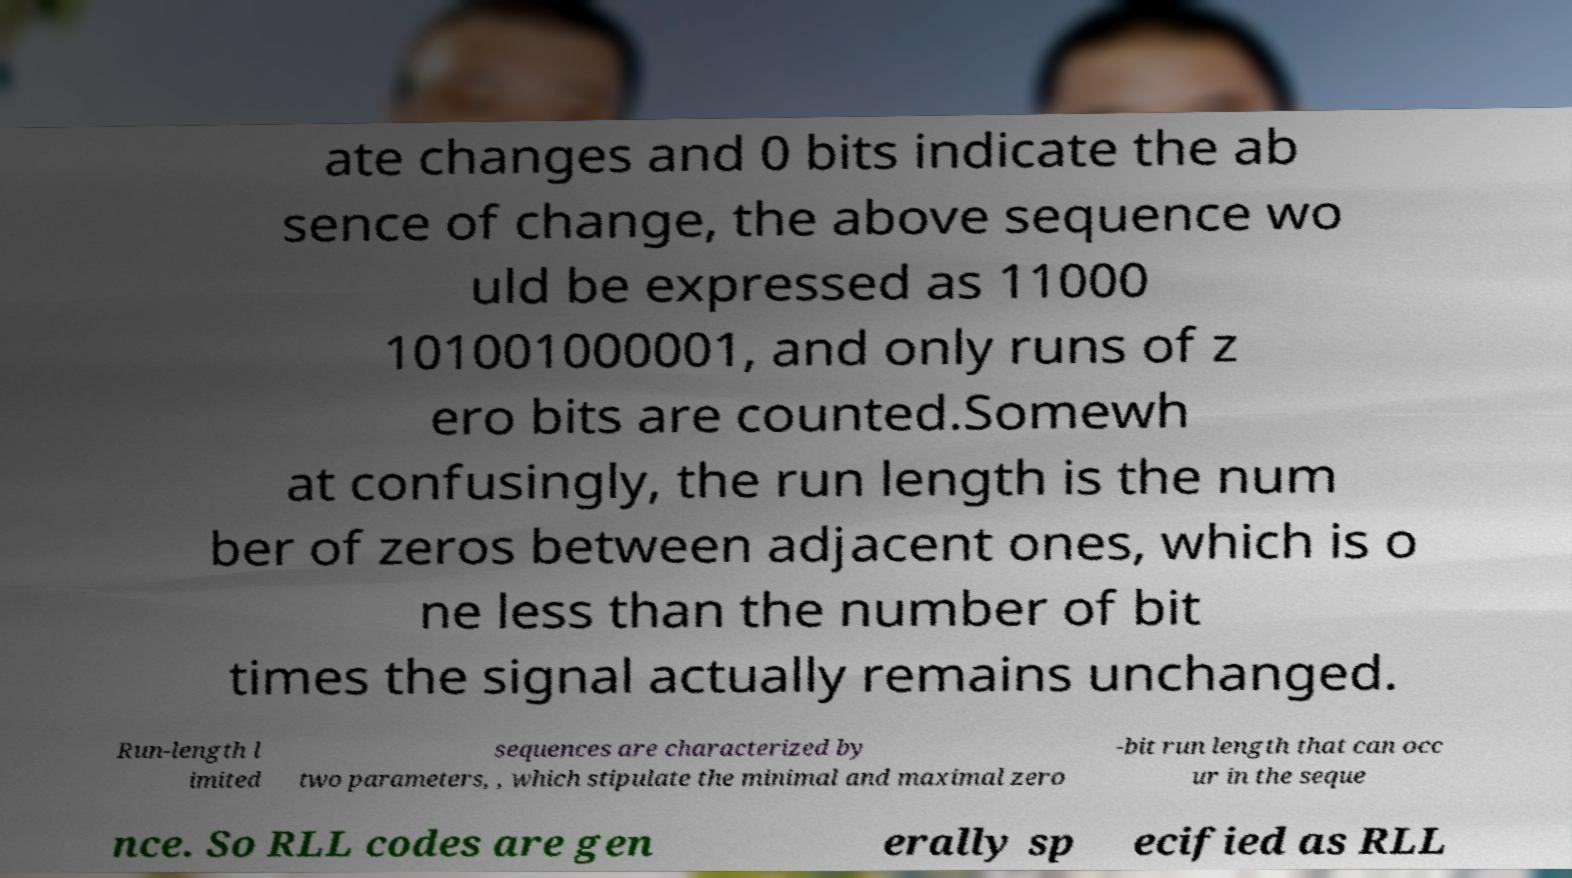For documentation purposes, I need the text within this image transcribed. Could you provide that? ate changes and 0 bits indicate the ab sence of change, the above sequence wo uld be expressed as 11000 101001000001, and only runs of z ero bits are counted.Somewh at confusingly, the run length is the num ber of zeros between adjacent ones, which is o ne less than the number of bit times the signal actually remains unchanged. Run-length l imited sequences are characterized by two parameters, , which stipulate the minimal and maximal zero -bit run length that can occ ur in the seque nce. So RLL codes are gen erally sp ecified as RLL 